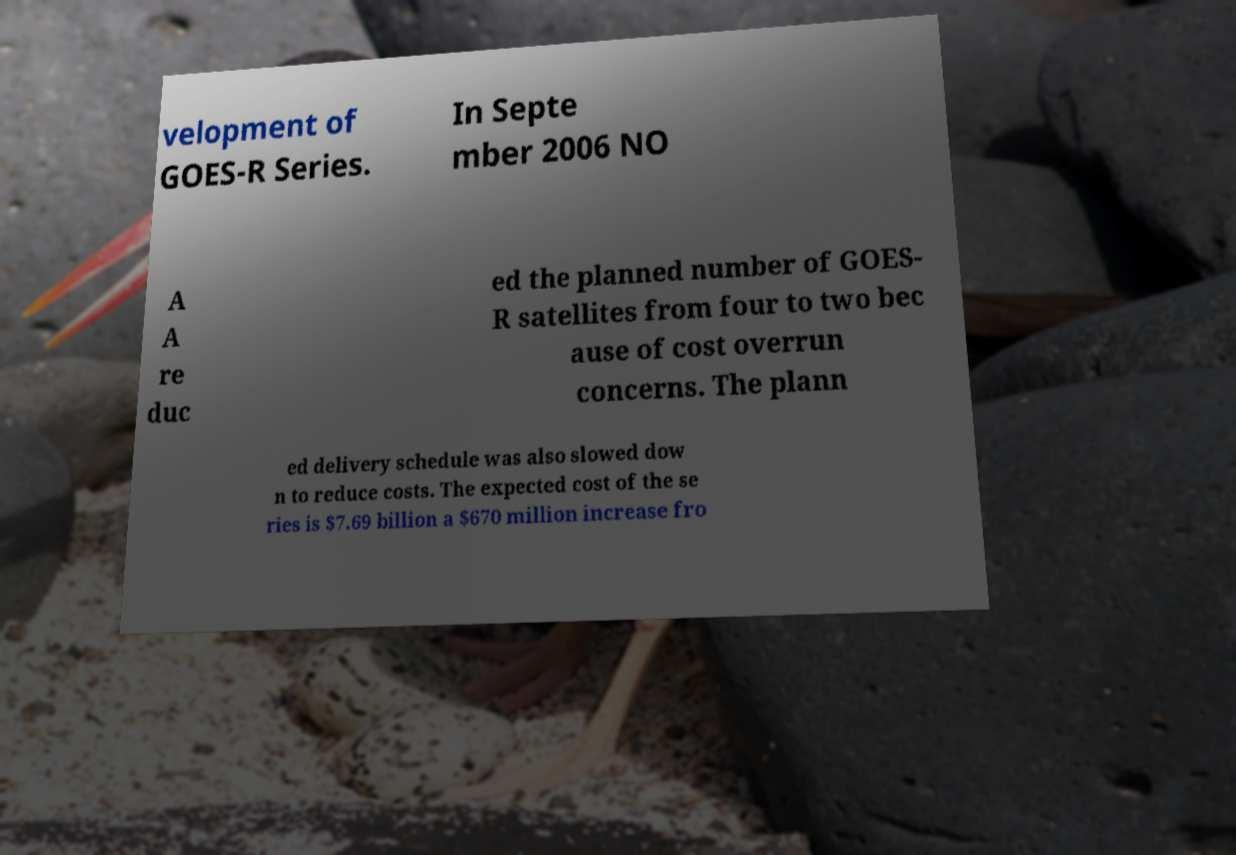Could you extract and type out the text from this image? velopment of GOES-R Series. In Septe mber 2006 NO A A re duc ed the planned number of GOES- R satellites from four to two bec ause of cost overrun concerns. The plann ed delivery schedule was also slowed dow n to reduce costs. The expected cost of the se ries is $7.69 billion a $670 million increase fro 